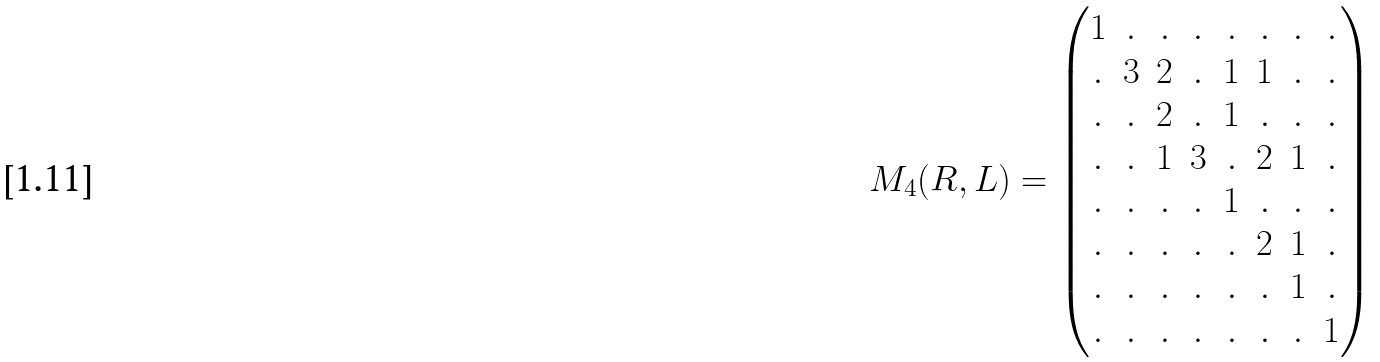<formula> <loc_0><loc_0><loc_500><loc_500>M _ { 4 } ( R , L ) = \left ( \begin{matrix} 1 & . & . & . & . & . & . & . \\ . & 3 & 2 & . & 1 & 1 & . & . \\ . & . & 2 & . & 1 & . & . & . \\ . & . & 1 & 3 & . & 2 & 1 & . \\ . & . & . & . & 1 & . & . & . \\ . & . & . & . & . & 2 & 1 & . \\ . & . & . & . & . & . & 1 & . \\ . & . & . & . & . & . & . & 1 \end{matrix} \right )</formula> 